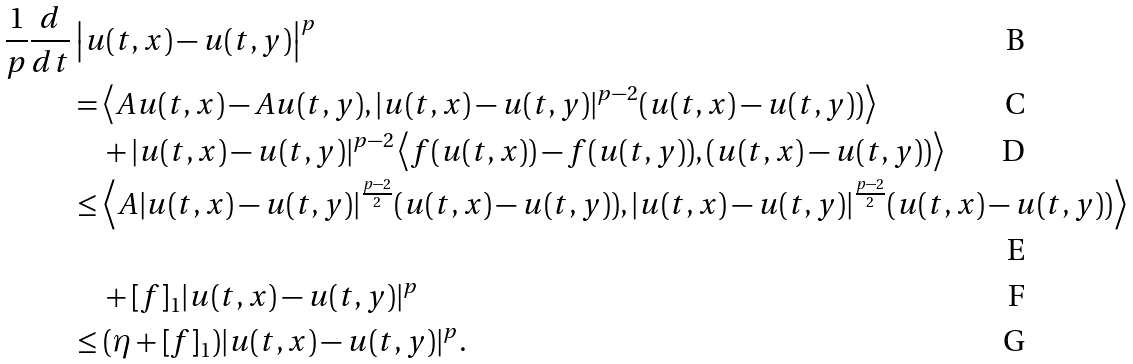<formula> <loc_0><loc_0><loc_500><loc_500>\frac { 1 } { p } \frac { d } { d t } & \left | u ( t , x ) - u ( t , y ) \right | ^ { p } \\ & = \left \langle A u ( t , x ) - A u ( t , y ) , | u ( t , x ) - u ( t , y ) | ^ { p - 2 } ( u ( t , x ) - u ( t , y ) ) \right \rangle \\ & \quad + | u ( t , x ) - u ( t , y ) | ^ { p - 2 } \left \langle f ( u ( t , x ) ) - f ( u ( t , y ) ) , ( u ( t , x ) - u ( t , y ) ) \right \rangle \\ & \leq \left \langle A | u ( t , x ) - u ( t , y ) | ^ { \frac { p - 2 } { 2 } } ( u ( t , x ) - u ( t , y ) ) , | u ( t , x ) - u ( t , y ) | ^ { \frac { p - 2 } { 2 } } ( u ( t , x ) - u ( t , y ) ) \right \rangle \\ & \quad + [ f ] _ { 1 } | u ( t , x ) - u ( t , y ) | ^ { p } \\ & \leq ( \eta + [ f ] _ { 1 } ) | u ( t , x ) - u ( t , y ) | ^ { p } .</formula> 